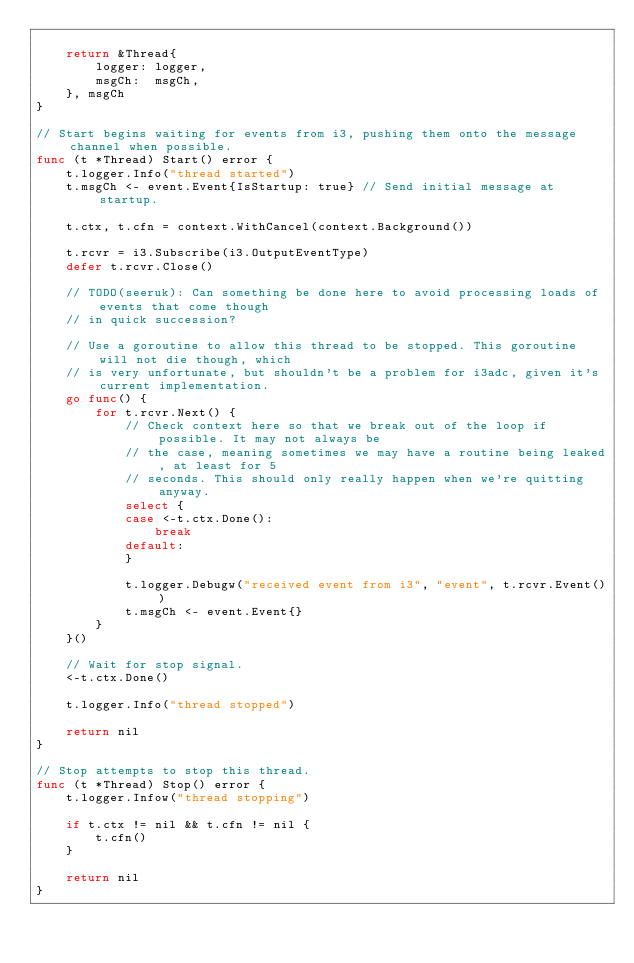Convert code to text. <code><loc_0><loc_0><loc_500><loc_500><_Go_>
	return &Thread{
		logger: logger,
		msgCh:  msgCh,
	}, msgCh
}

// Start begins waiting for events from i3, pushing them onto the message channel when possible.
func (t *Thread) Start() error {
	t.logger.Info("thread started")
	t.msgCh <- event.Event{IsStartup: true} // Send initial message at startup.

	t.ctx, t.cfn = context.WithCancel(context.Background())

	t.rcvr = i3.Subscribe(i3.OutputEventType)
	defer t.rcvr.Close()

	// TODO(seeruk): Can something be done here to avoid processing loads of events that come though
	// in quick succession?

	// Use a goroutine to allow this thread to be stopped. This goroutine will not die though, which
	// is very unfortunate, but shouldn't be a problem for i3adc, given it's current implementation.
	go func() {
		for t.rcvr.Next() {
			// Check context here so that we break out of the loop if possible. It may not always be
			// the case, meaning sometimes we may have a routine being leaked, at least for 5
			// seconds. This should only really happen when we're quitting anyway.
			select {
			case <-t.ctx.Done():
				break
			default:
			}

			t.logger.Debugw("received event from i3", "event", t.rcvr.Event())
			t.msgCh <- event.Event{}
		}
	}()

	// Wait for stop signal.
	<-t.ctx.Done()

	t.logger.Info("thread stopped")

	return nil
}

// Stop attempts to stop this thread.
func (t *Thread) Stop() error {
	t.logger.Infow("thread stopping")

	if t.ctx != nil && t.cfn != nil {
		t.cfn()
	}

	return nil
}
</code> 